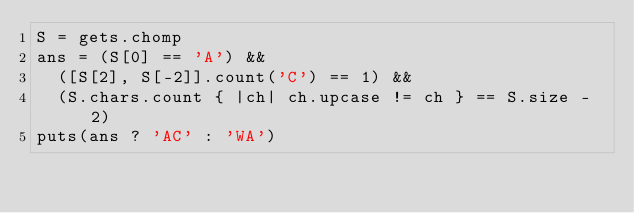Convert code to text. <code><loc_0><loc_0><loc_500><loc_500><_Ruby_>S = gets.chomp
ans = (S[0] == 'A') &&
  ([S[2], S[-2]].count('C') == 1) &&
  (S.chars.count { |ch| ch.upcase != ch } == S.size - 2)
puts(ans ? 'AC' : 'WA')
</code> 